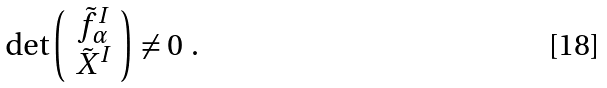<formula> <loc_0><loc_0><loc_500><loc_500>\det \left ( \begin{array} { c } \tilde { f } _ { \alpha } ^ { I } \\ \tilde { X } ^ { I } \end{array} \right ) \ne 0 \ .</formula> 